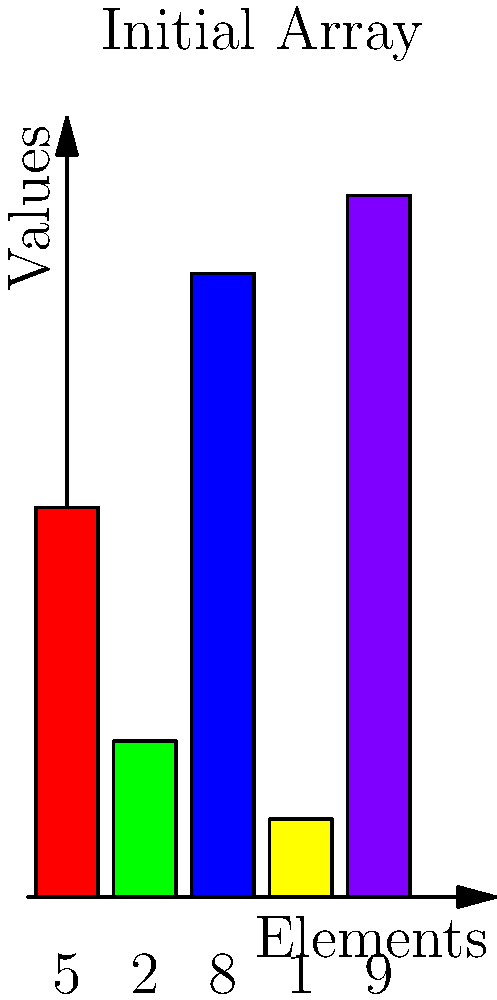Create a Python function that implements the Bubble Sort algorithm to sort a list of numbers in ascending order. The function should also generate and display bar charts showing the state of the list after each pass of the algorithm. Given the initial list [5, 2, 8, 1, 9], how many passes will the Bubble Sort algorithm require to fully sort the list? To solve this problem, let's go through the Bubble Sort algorithm step by step:

1. Initial state: [5, 2, 8, 1, 9]

2. First pass:
   - Compare 5 and 2: Swap -> [2, 5, 8, 1, 9]
   - Compare 5 and 8: No swap
   - Compare 8 and 1: Swap -> [2, 5, 1, 8, 9]
   - Compare 8 and 9: No swap
   After first pass: [2, 5, 1, 8, 9]

3. Second pass:
   - Compare 2 and 5: No swap
   - Compare 5 and 1: Swap -> [2, 1, 5, 8, 9]
   - Compare 5 and 8: No swap
   - Compare 8 and 9: No swap
   After second pass: [2, 1, 5, 8, 9]

4. Third pass:
   - Compare 2 and 1: Swap -> [1, 2, 5, 8, 9]
   - Compare 2 and 5: No swap
   - Compare 5 and 8: No swap
   - Compare 8 and 9: No swap
   After third pass: [1, 2, 5, 8, 9]

5. Fourth pass:
   - No swaps occur, indicating the list is fully sorted

The Bubble Sort algorithm requires 4 passes to fully sort the given list. The last pass is necessary to confirm that no more swaps are needed, indicating that the list is completely sorted.
Answer: 4 passes 